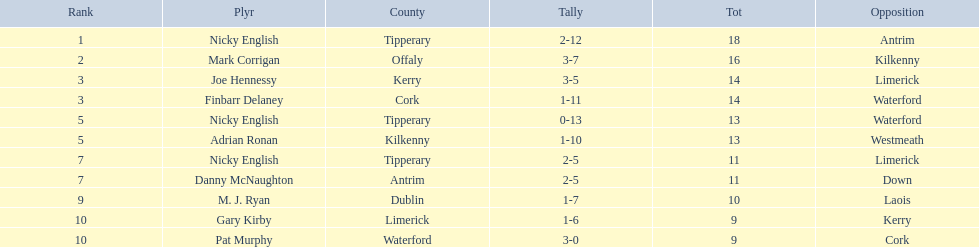What is the first name on the list? Nicky English. 